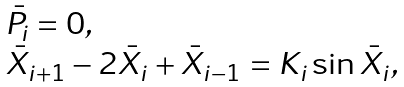Convert formula to latex. <formula><loc_0><loc_0><loc_500><loc_500>\begin{array} l \bar { P } _ { i } = 0 , \\ \bar { X } _ { i + 1 } - 2 \bar { X } _ { i } + \bar { X } _ { i - 1 } = K _ { i } \sin \bar { X } _ { i } , \end{array}</formula> 